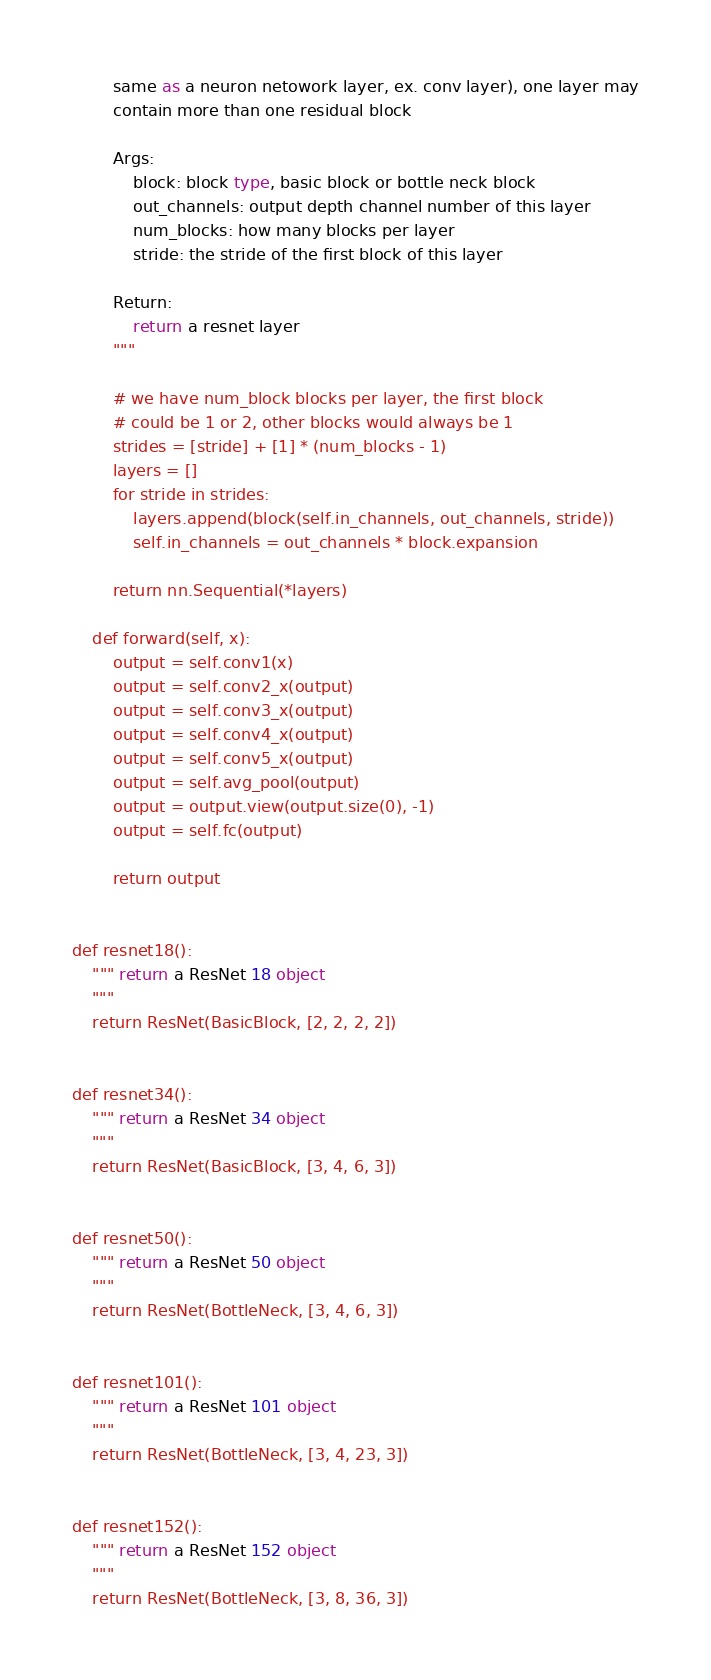<code> <loc_0><loc_0><loc_500><loc_500><_Python_>        same as a neuron netowork layer, ex. conv layer), one layer may
        contain more than one residual block

        Args:
            block: block type, basic block or bottle neck block
            out_channels: output depth channel number of this layer
            num_blocks: how many blocks per layer
            stride: the stride of the first block of this layer

        Return:
            return a resnet layer
        """

        # we have num_block blocks per layer, the first block
        # could be 1 or 2, other blocks would always be 1
        strides = [stride] + [1] * (num_blocks - 1)
        layers = []
        for stride in strides:
            layers.append(block(self.in_channels, out_channels, stride))
            self.in_channels = out_channels * block.expansion

        return nn.Sequential(*layers)

    def forward(self, x):
        output = self.conv1(x)
        output = self.conv2_x(output)
        output = self.conv3_x(output)
        output = self.conv4_x(output)
        output = self.conv5_x(output)
        output = self.avg_pool(output)
        output = output.view(output.size(0), -1)
        output = self.fc(output)

        return output


def resnet18():
    """ return a ResNet 18 object
    """
    return ResNet(BasicBlock, [2, 2, 2, 2])


def resnet34():
    """ return a ResNet 34 object
    """
    return ResNet(BasicBlock, [3, 4, 6, 3])


def resnet50():
    """ return a ResNet 50 object
    """
    return ResNet(BottleNeck, [3, 4, 6, 3])


def resnet101():
    """ return a ResNet 101 object
    """
    return ResNet(BottleNeck, [3, 4, 23, 3])


def resnet152():
    """ return a ResNet 152 object
    """
    return ResNet(BottleNeck, [3, 8, 36, 3])
</code> 